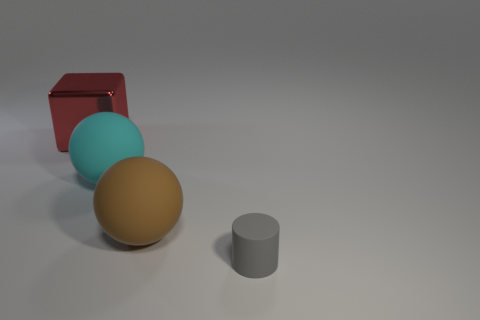Add 1 big blocks. How many objects exist? 5 Subtract all cubes. How many objects are left? 3 Subtract 0 blue cylinders. How many objects are left? 4 Subtract all matte things. Subtract all cyan metallic cylinders. How many objects are left? 1 Add 2 gray cylinders. How many gray cylinders are left? 3 Add 1 big cyan rubber spheres. How many big cyan rubber spheres exist? 2 